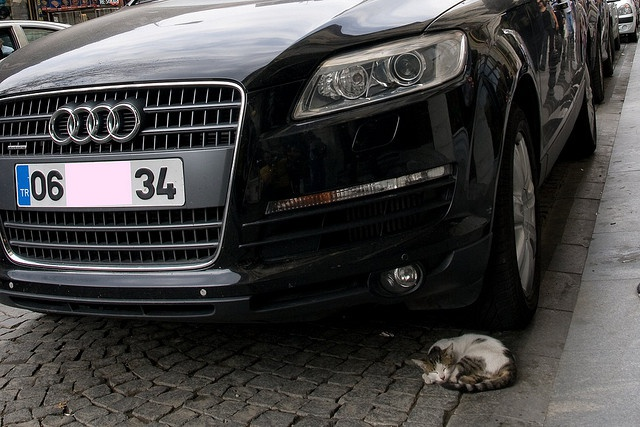Describe the objects in this image and their specific colors. I can see car in black, darkblue, gray, lightgray, and darkgray tones, cat in darkblue, black, darkgray, and gray tones, car in darkblue, black, gray, and darkgray tones, car in darkblue, black, gray, darkgray, and lightgray tones, and car in darkblue, black, darkgray, gray, and lightgray tones in this image. 